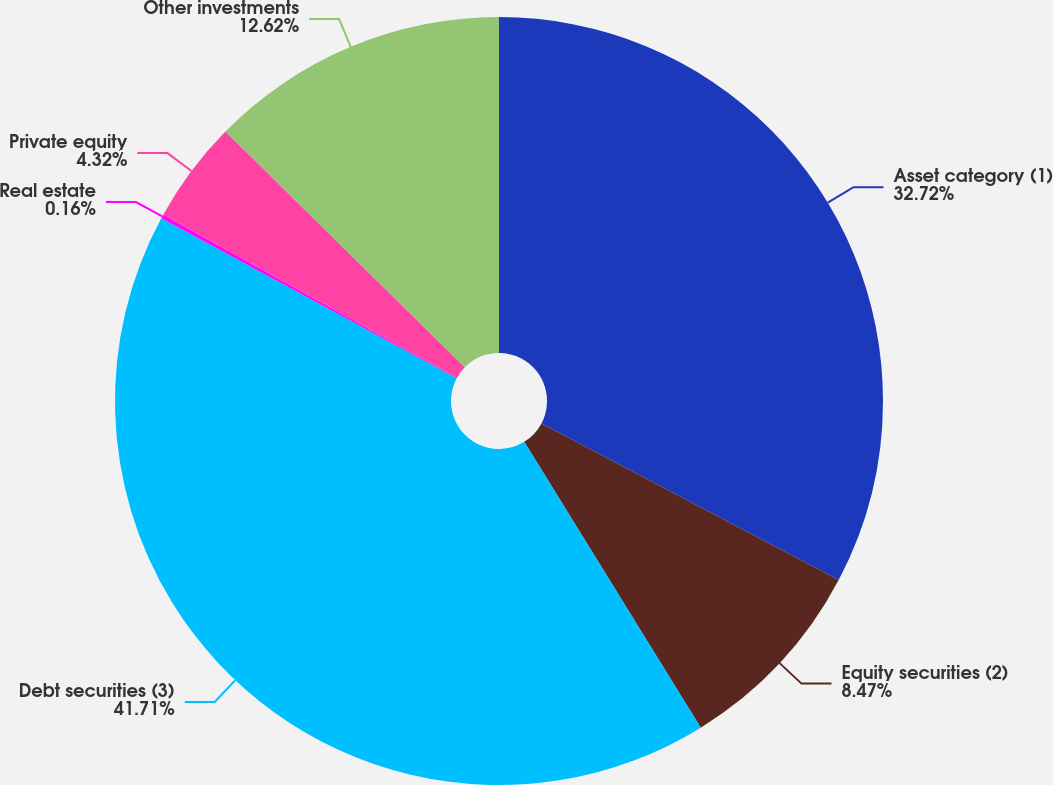Convert chart. <chart><loc_0><loc_0><loc_500><loc_500><pie_chart><fcel>Asset category (1)<fcel>Equity securities (2)<fcel>Debt securities (3)<fcel>Real estate<fcel>Private equity<fcel>Other investments<nl><fcel>32.72%<fcel>8.47%<fcel>41.7%<fcel>0.16%<fcel>4.32%<fcel>12.62%<nl></chart> 